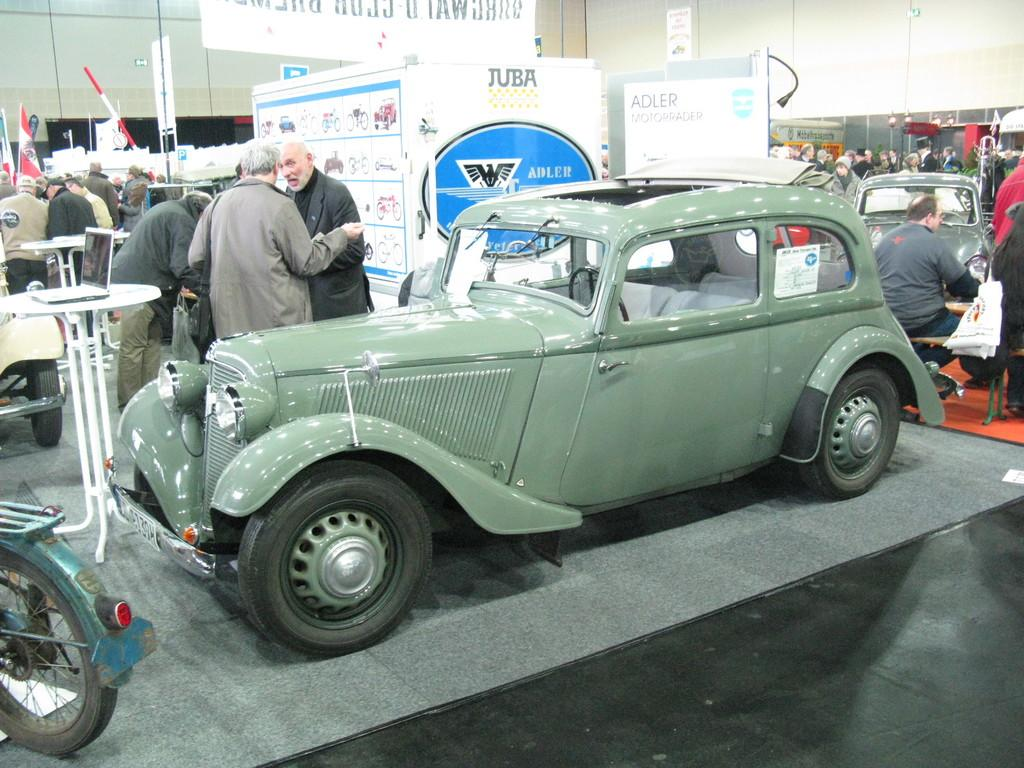What is the main subject in the middle of the image? There is a car in the middle of the image. What can be seen on the left side of the image? There are two women standing on the left side of the image. What are the women doing in the image? The women are talking to each other. Can you see any goldfish swimming in the car's engine in the image? No, there are no goldfish present in the image, and they would not be able to swim in a car's engine. 